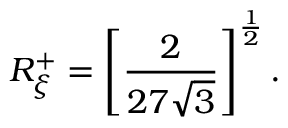Convert formula to latex. <formula><loc_0><loc_0><loc_500><loc_500>R _ { \xi } ^ { + } = \left [ \frac { 2 } { 2 7 \sqrt { 3 } } \right ] ^ { \frac { 1 } { 2 } } .</formula> 